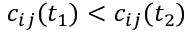<formula> <loc_0><loc_0><loc_500><loc_500>c _ { i j } ( t _ { 1 } ) < c _ { i j } ( t _ { 2 } )</formula> 